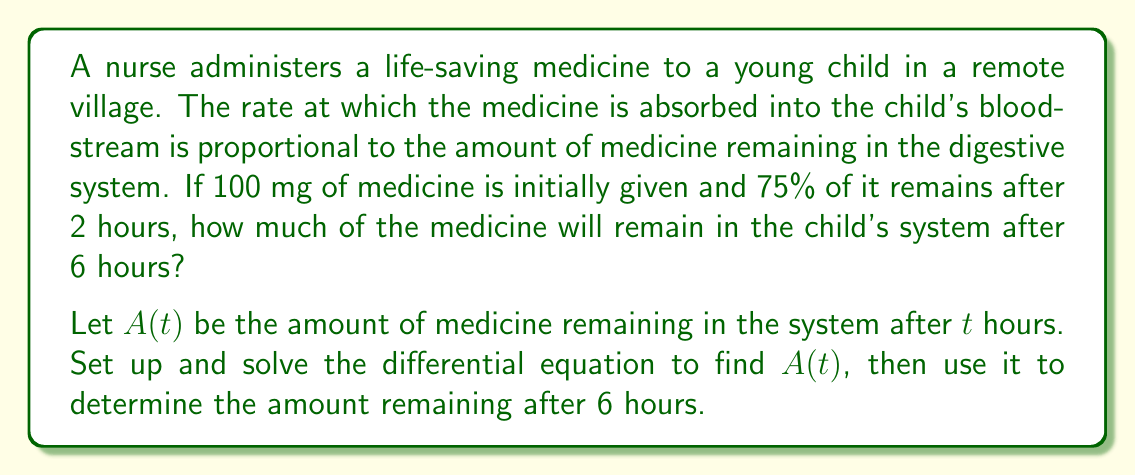Can you solve this math problem? Let's approach this step-by-step:

1) We're told that the rate of absorption is proportional to the amount remaining. This can be expressed as a differential equation:

   $$\frac{dA}{dt} = -kA$$

   where $k$ is the proportionality constant (absorption rate constant).

2) We know that $A(0) = 100$ mg (initial amount) and $A(2) = 75$ mg (75% of 100 mg).

3) The general solution to this differential equation is:

   $$A(t) = A_0e^{-kt}$$

   where $A_0$ is the initial amount.

4) Using the initial condition:

   $$A(0) = A_0e^{-k(0)} = A_0 = 100$$

5) Now we can use the information at $t=2$ to find $k$:

   $$75 = 100e^{-2k}$$

   $$\ln(0.75) = -2k$$

   $$k = -\frac{\ln(0.75)}{2} \approx 0.1438$$

6) Now we have our complete function:

   $$A(t) = 100e^{-0.1438t}$$

7) To find the amount remaining after 6 hours, we evaluate $A(6)$:

   $$A(6) = 100e^{-0.1438(6)} \approx 42.19$$

Therefore, approximately 42.19 mg of medicine will remain in the child's system after 6 hours.
Answer: 42.19 mg 